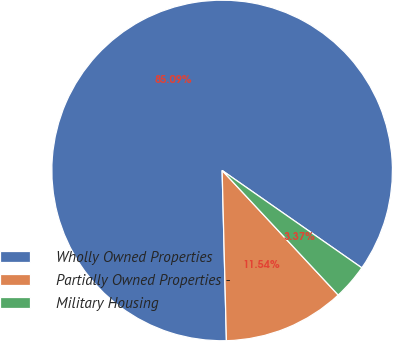<chart> <loc_0><loc_0><loc_500><loc_500><pie_chart><fcel>Wholly Owned Properties<fcel>Partially Owned Properties -<fcel>Military Housing<nl><fcel>85.09%<fcel>11.54%<fcel>3.37%<nl></chart> 